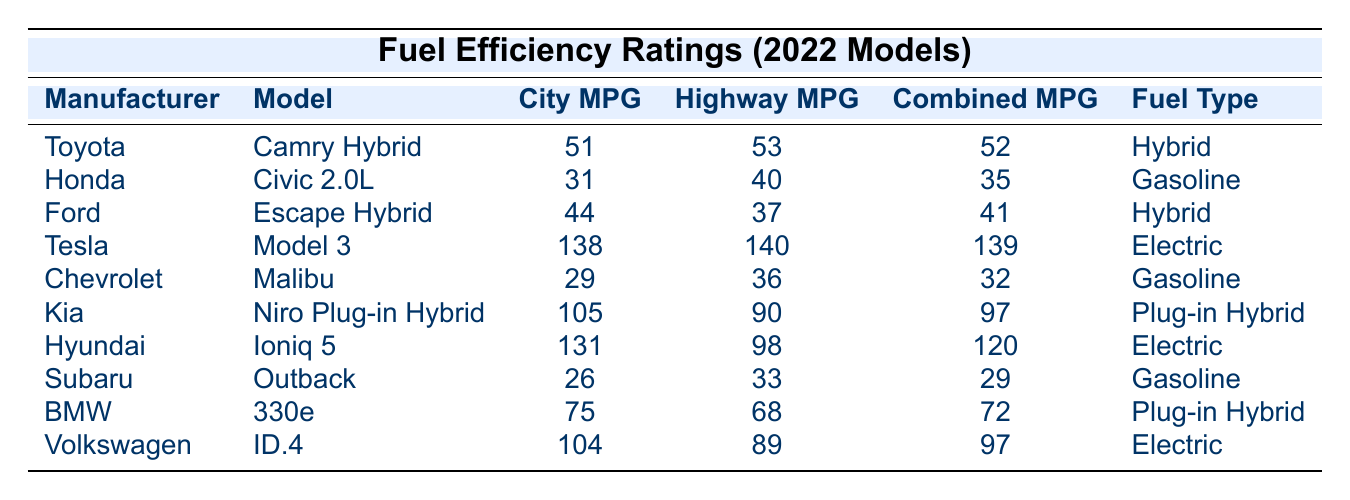What is the fuel type of the Tesla Model 3? The Tesla Model 3's fuel type is listed in the table under the 'Fuel Type' column. It states "Electric."
Answer: Electric Which car model has the highest highway MPG? To find the highest highway MPG, we compare the values under the 'Highway MPG' column. The Tesla Model 3 has the highest value of 140.
Answer: Tesla Model 3 What is the combined MPG of the Kia Niro Plug-in Hybrid? The combined MPG for the Kia Niro Plug-in Hybrid is shown under the 'Combined MPG' column, where it states "97."
Answer: 97 What is the difference in combined MPG between the Kia Niro Plug-in Hybrid and the Honda Civic 2.0L? The combined MPG for Kia Niro Plug-in Hybrid is 97, and for the Honda Civic 2.0L, it is 35. The difference is 97 - 35 = 62.
Answer: 62 Which manufacturers have models with hybrid fuel types? Looking at the table, the manufacturers with hybrid fuel types are Toyota (Camry Hybrid), Ford (Escape Hybrid), and BMW (330e).
Answer: Toyota, Ford, and BMW Is the Hyundai Ioniq 5 more fuel-efficient than the Chevrolet Malibu? Comparing the combined MPG values, the Hyundai Ioniq 5 has 120, while the Chevrolet Malibu has 32. Since 120 is greater than 32, it is indeed more fuel-efficient.
Answer: Yes What is the average city MPG of all the electric vehicles listed? The electric vehicles are Tesla Model 3 (138), Hyundai Ioniq 5 (131), Kia Niro Plug-in Hybrid (105), and Volkswagen ID.4 (104). The average is (138 + 131 + 105 + 104) / 4 = 119.5.
Answer: 119.5 Which model has the lowest highway MPG, and what is that value? Scanning the 'Highway MPG' column, the Subaru Outback has the lowest value of 33.
Answer: Subaru Outback, 33 How many car models listed have a city MPG greater than 50? Checking the 'City MPG' column, only the Toyota Camry Hybrid (51) and the Kia Niro Plug-in Hybrid (105) exceed 50, totaling two models.
Answer: 2 What is the relationship between city MPG and combined MPG for the Ford Escape Hybrid? The city MPG is 44, and the combined MPG is 41. This indicates that the city MPG is higher than the combined MPG, suggesting better fuel efficiency in city driving conditions.
Answer: City MPG is higher than combined MPG 